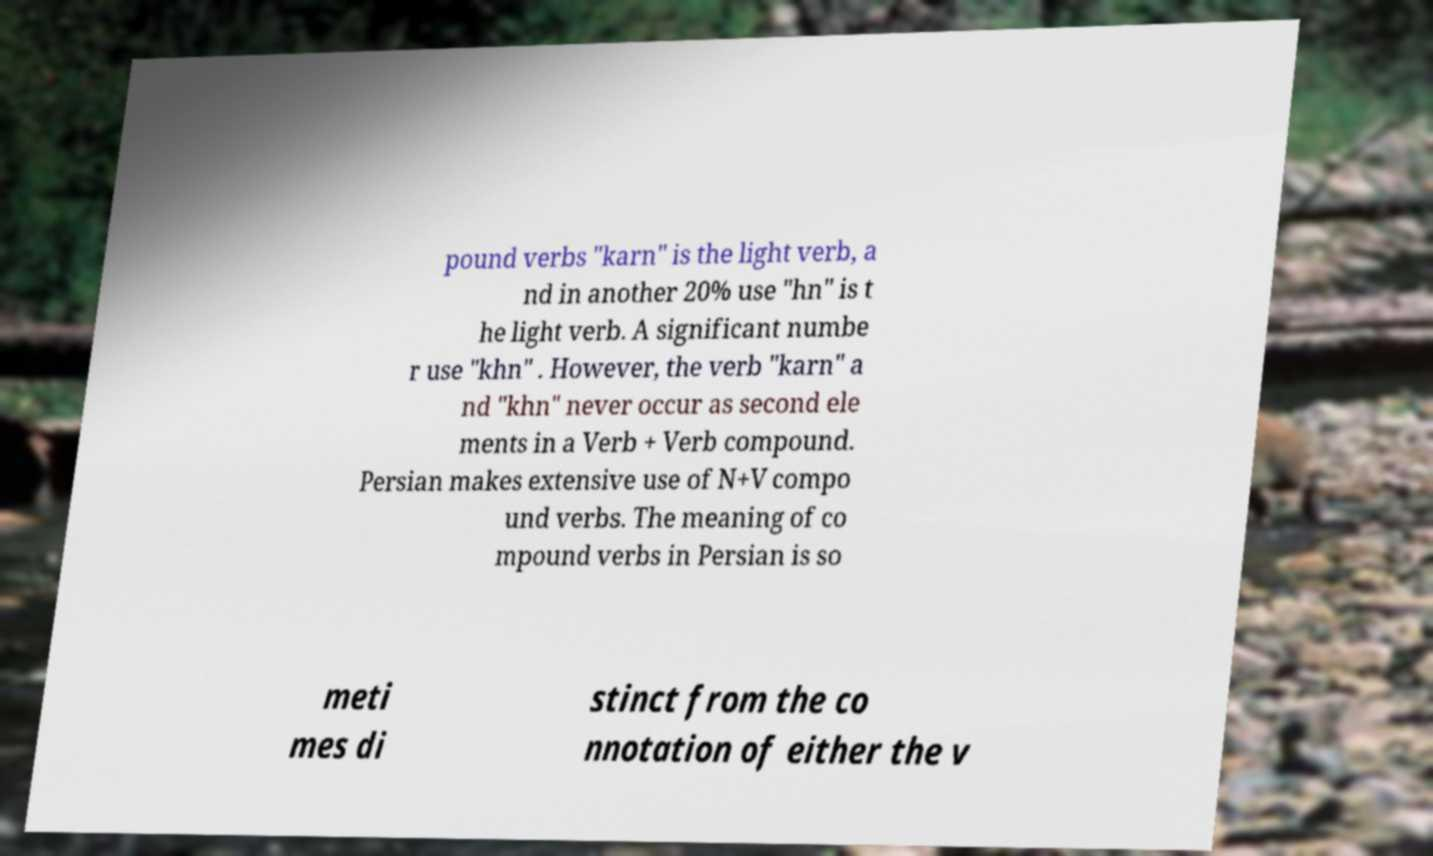Could you assist in decoding the text presented in this image and type it out clearly? pound verbs "karn" is the light verb, a nd in another 20% use "hn" is t he light verb. A significant numbe r use "khn" . However, the verb "karn" a nd "khn" never occur as second ele ments in a Verb + Verb compound. Persian makes extensive use of N+V compo und verbs. The meaning of co mpound verbs in Persian is so meti mes di stinct from the co nnotation of either the v 